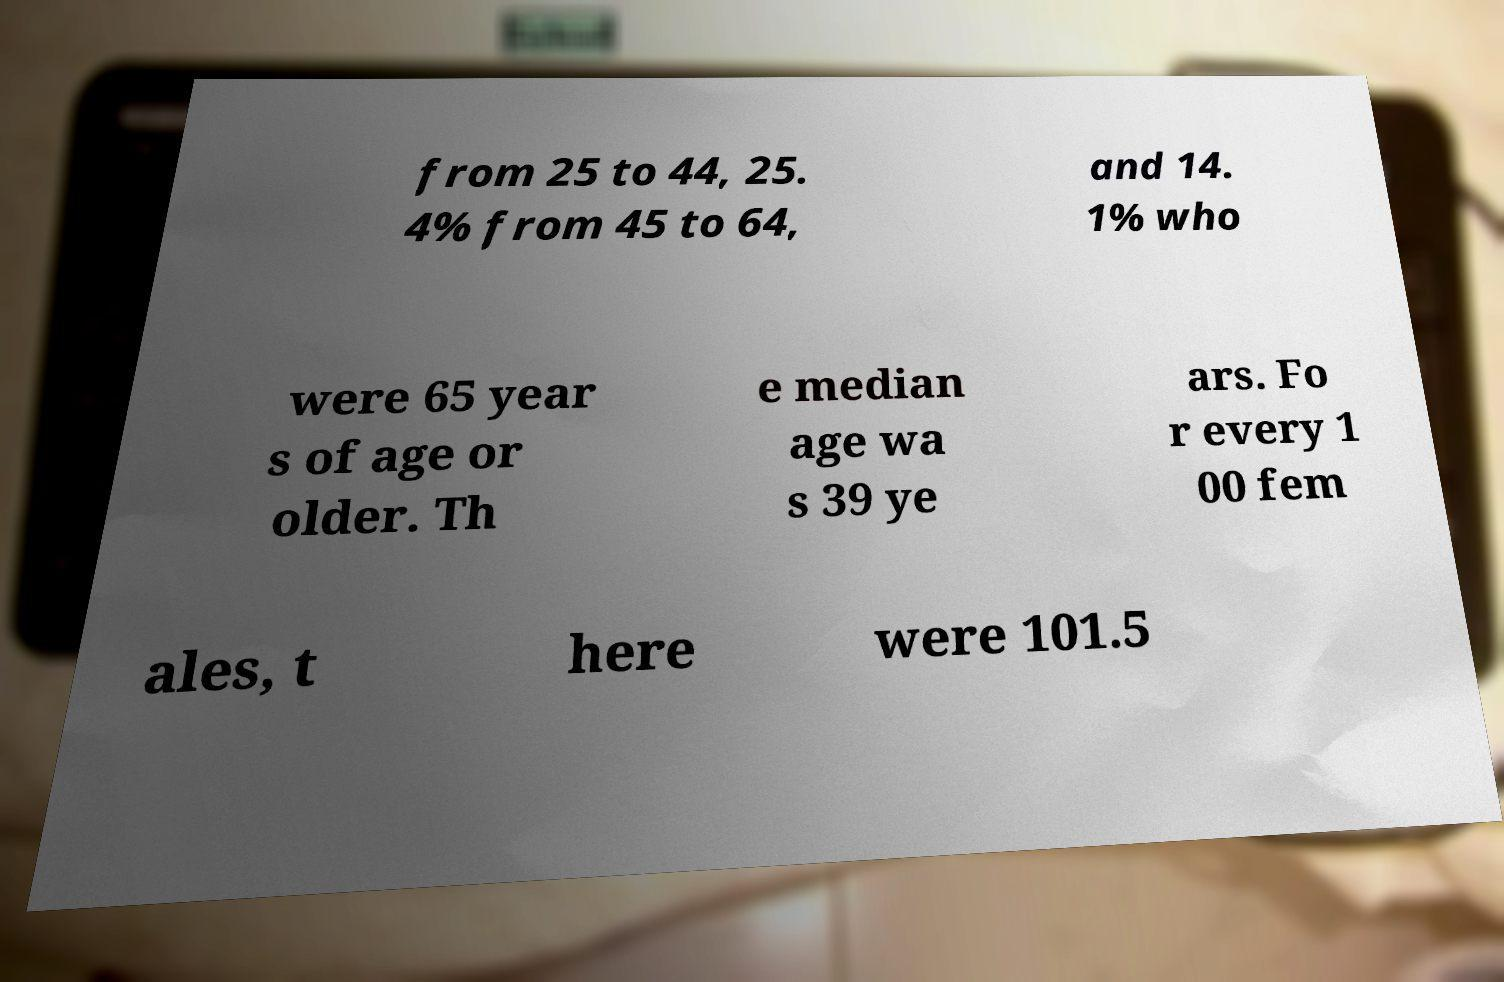I need the written content from this picture converted into text. Can you do that? from 25 to 44, 25. 4% from 45 to 64, and 14. 1% who were 65 year s of age or older. Th e median age wa s 39 ye ars. Fo r every 1 00 fem ales, t here were 101.5 